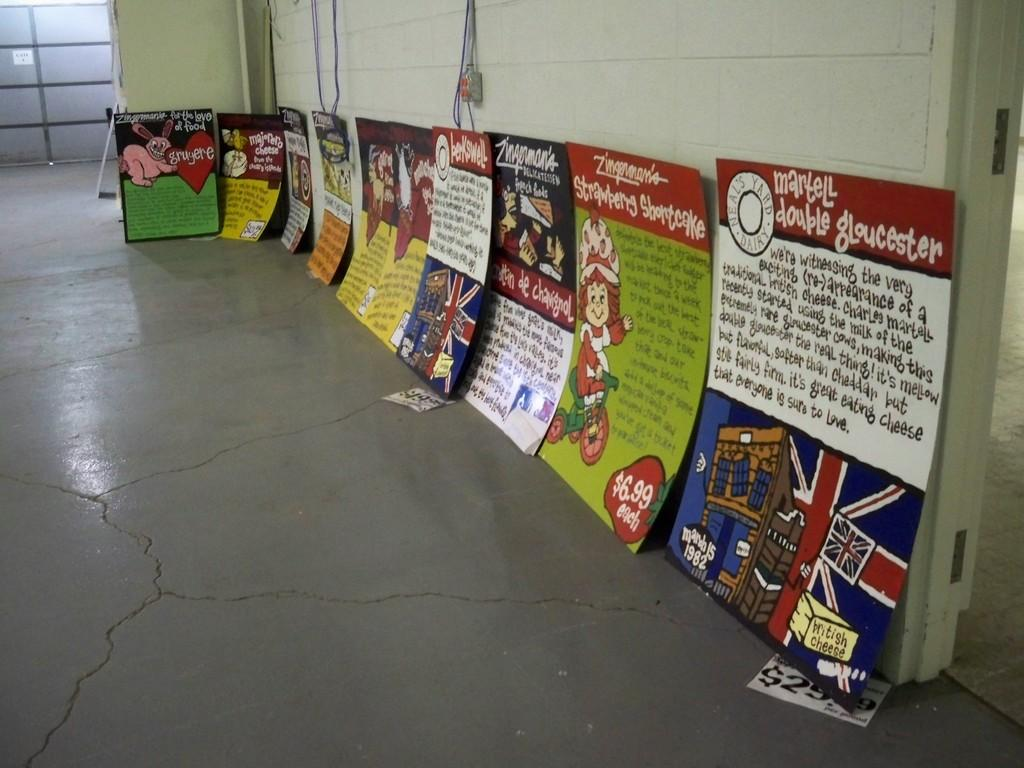What type of decorations are present in the image? There are posters in the image. What is the surface that the posters are attached to? There is a wall at the top of the image. What is the surface beneath the posters? There is a floor at the bottom of the image. What type of spark can be seen coming from the veil in the image? There is no spark or veil present in the image; it only features posters on a wall and a floor. 